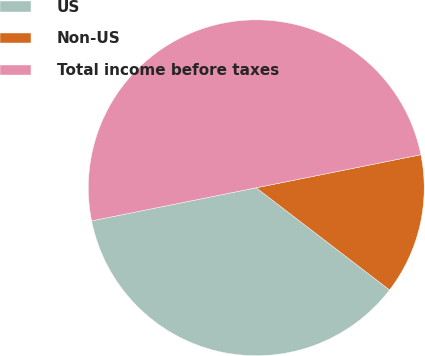Convert chart to OTSL. <chart><loc_0><loc_0><loc_500><loc_500><pie_chart><fcel>US<fcel>Non-US<fcel>Total income before taxes<nl><fcel>36.44%<fcel>13.56%<fcel>50.0%<nl></chart> 